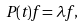Convert formula to latex. <formula><loc_0><loc_0><loc_500><loc_500>P ( t ) f = \lambda f ,</formula> 